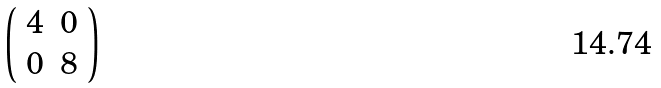<formula> <loc_0><loc_0><loc_500><loc_500>\left ( \begin{array} { c c } 4 & 0 \\ 0 & 8 \end{array} \right )</formula> 